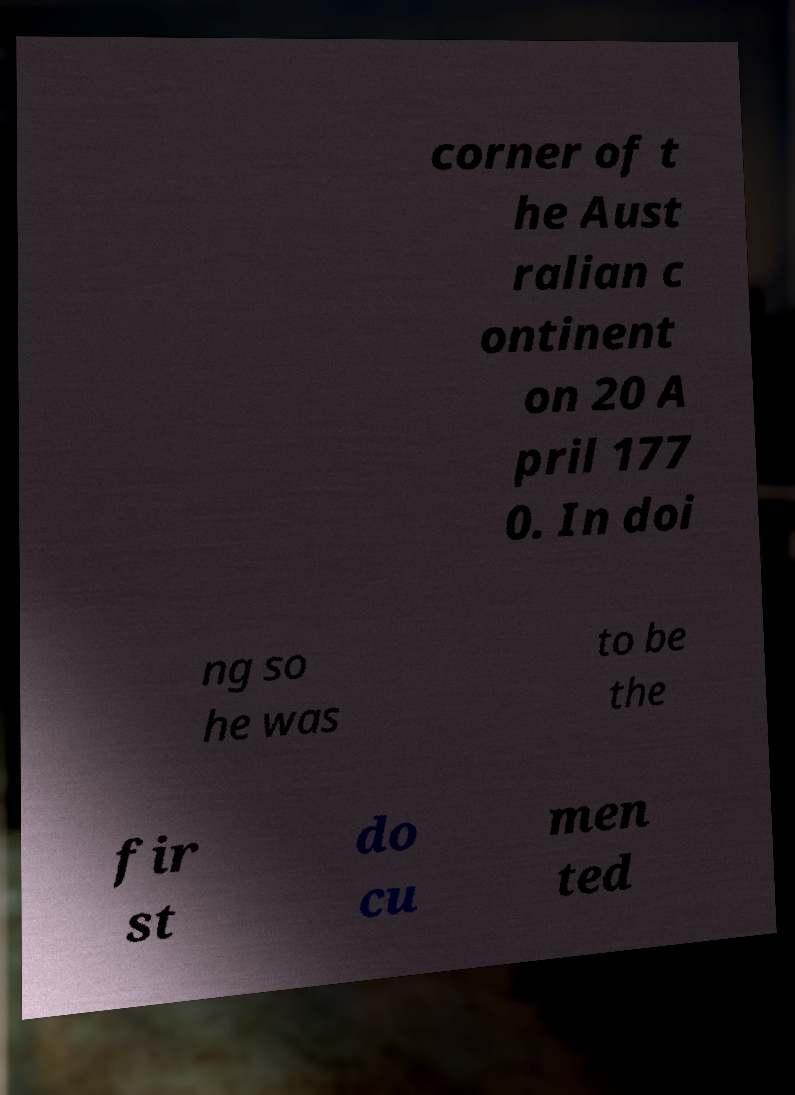Please read and relay the text visible in this image. What does it say? corner of t he Aust ralian c ontinent on 20 A pril 177 0. In doi ng so he was to be the fir st do cu men ted 